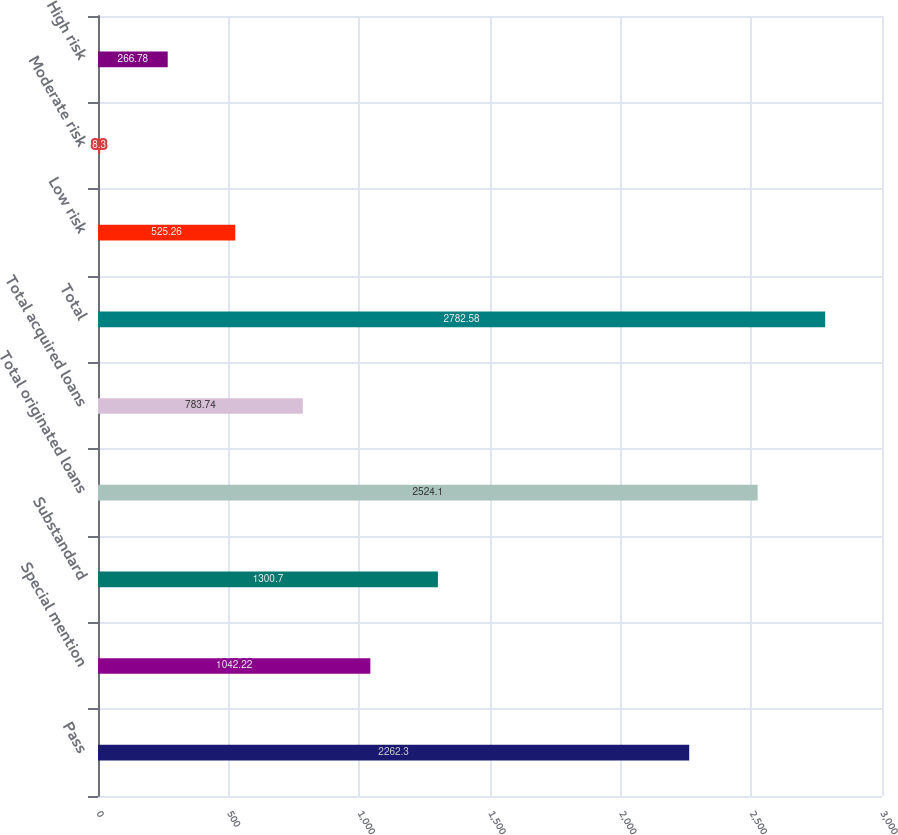<chart> <loc_0><loc_0><loc_500><loc_500><bar_chart><fcel>Pass<fcel>Special mention<fcel>Substandard<fcel>Total originated loans<fcel>Total acquired loans<fcel>Total<fcel>Low risk<fcel>Moderate risk<fcel>High risk<nl><fcel>2262.3<fcel>1042.22<fcel>1300.7<fcel>2524.1<fcel>783.74<fcel>2782.58<fcel>525.26<fcel>8.3<fcel>266.78<nl></chart> 